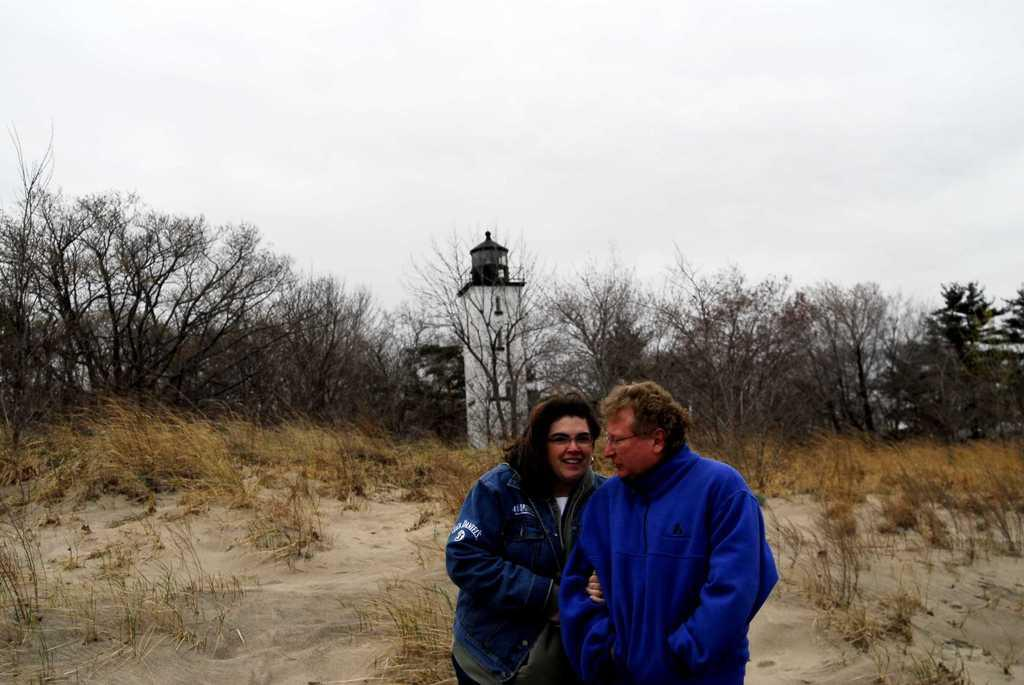How many people are in the image? There are two persons standing in the middle of the image. What are the people doing in the image? The persons are smiling. What type of vegetation can be seen in the image? There are plants and trees visible in the image. What structure is present in the image? There is a tower in the image. What is visible in the sky at the top of the image? There are clouds in the sky at the top of the image. What type of clam is being used as a form of authority in the image? There is no clam present in the image, and therefore no such authority can be observed. How many apples are visible in the image? There are no apples present in the image. 